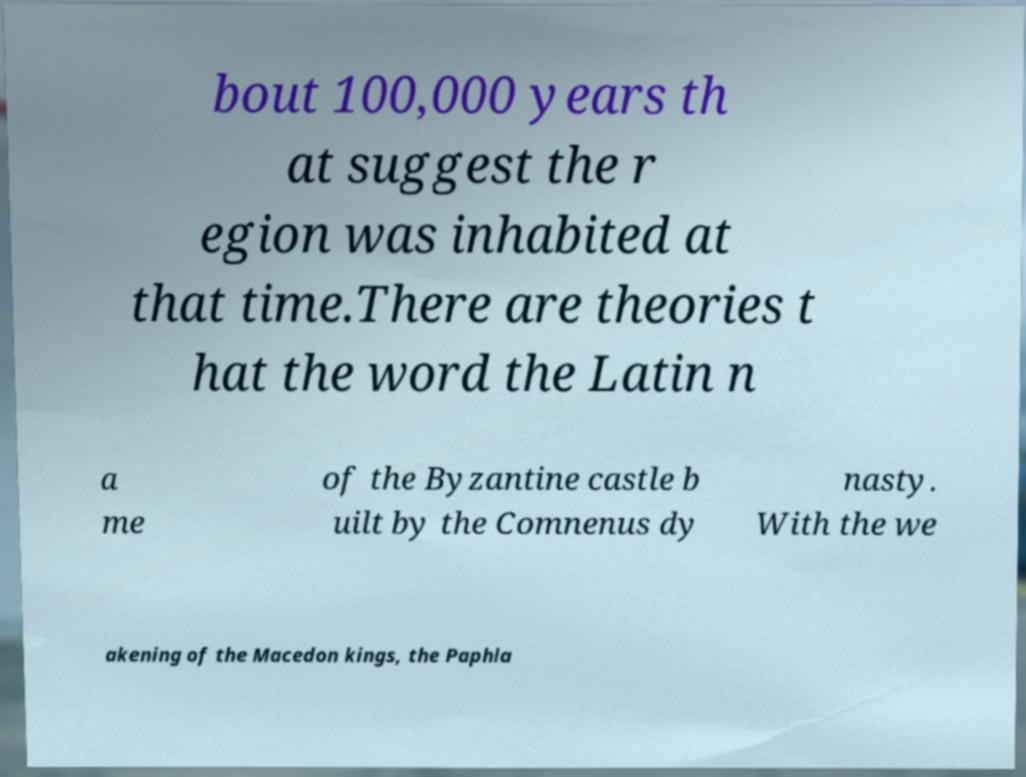I need the written content from this picture converted into text. Can you do that? bout 100,000 years th at suggest the r egion was inhabited at that time.There are theories t hat the word the Latin n a me of the Byzantine castle b uilt by the Comnenus dy nasty. With the we akening of the Macedon kings, the Paphla 